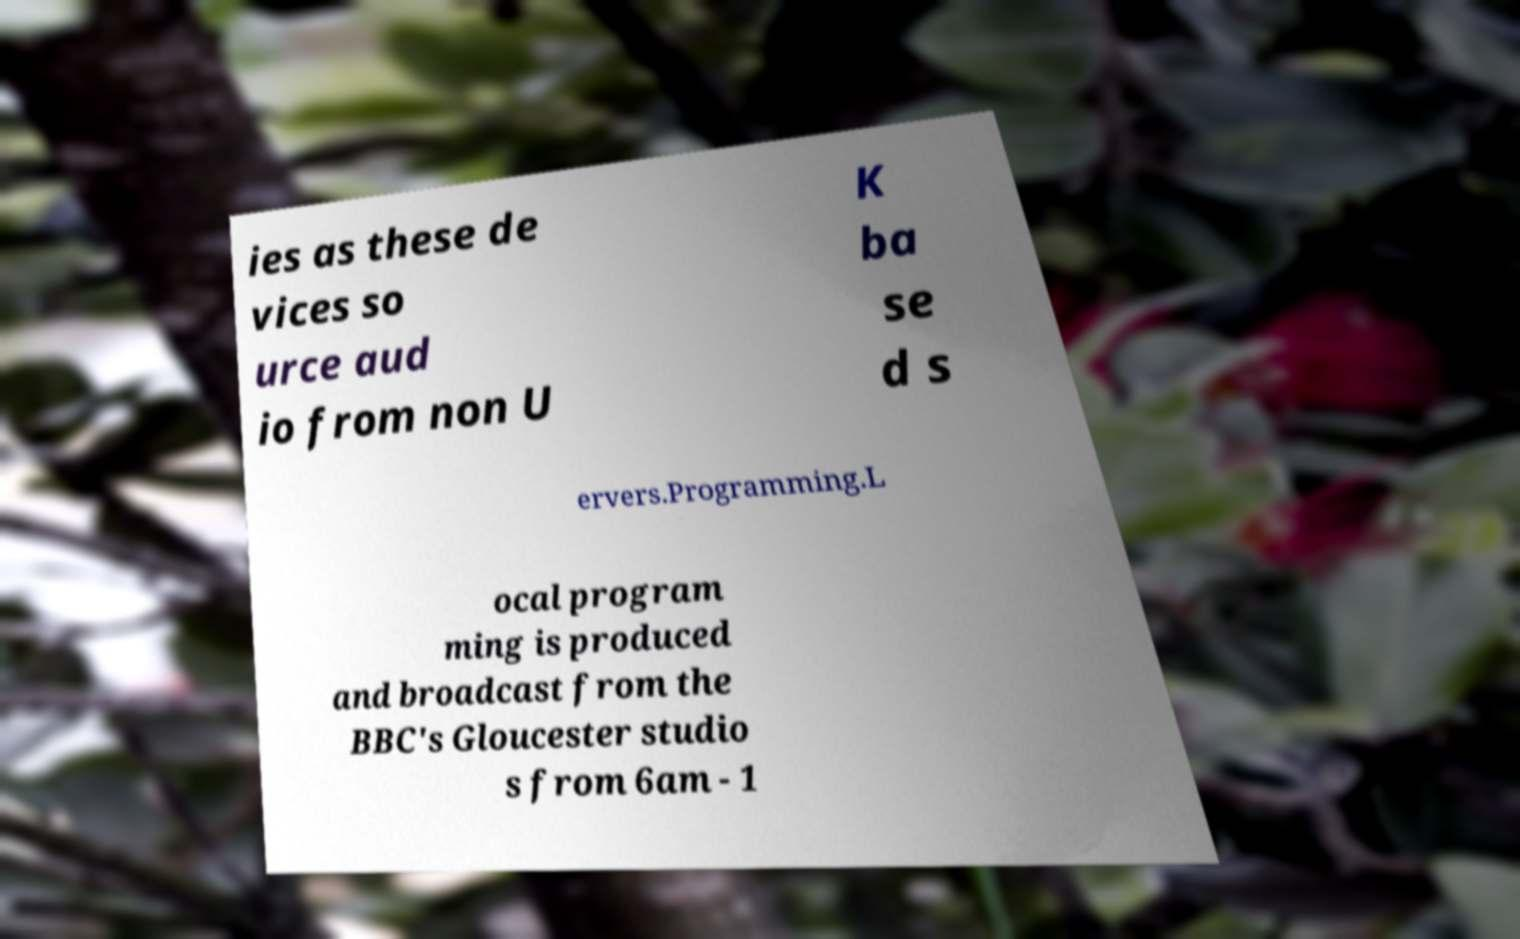Please read and relay the text visible in this image. What does it say? ies as these de vices so urce aud io from non U K ba se d s ervers.Programming.L ocal program ming is produced and broadcast from the BBC's Gloucester studio s from 6am - 1 